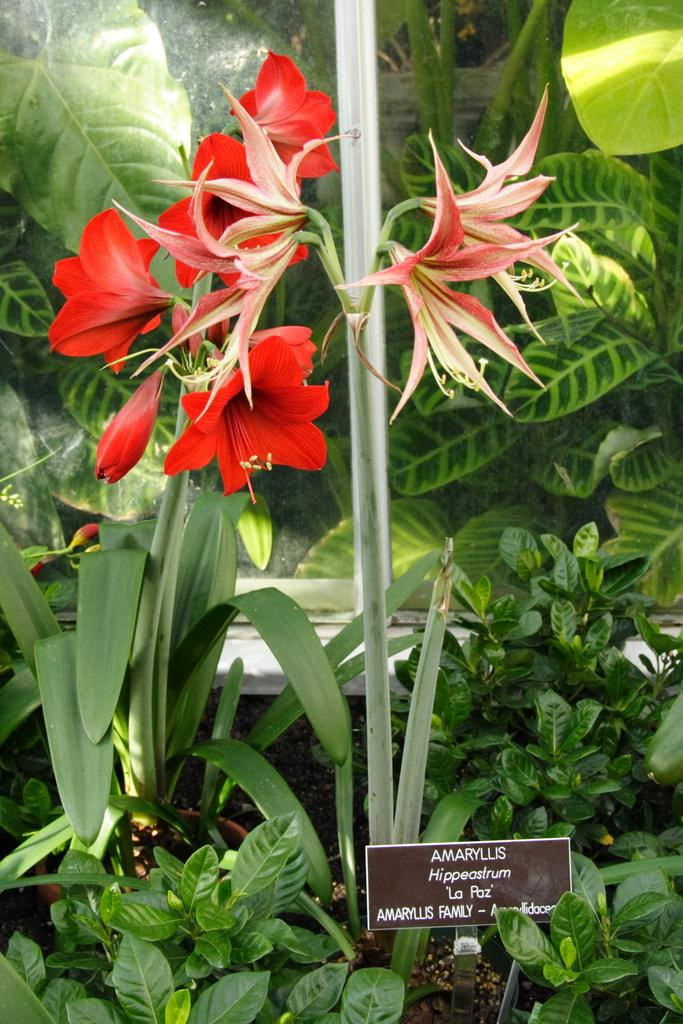What type of plant is in the image? There is a plant in the image with red flowers and green leaves. What colors are present in the plant? The plant has red flowers and green leaves. What else can be seen in the image besides the plant? There is a brown color board in the image. What is the purpose of the board? Something is written on the board, suggesting it may be used for communication or displaying information. Where is the crowd gathered around the plant in the image? There is no crowd present in the image; it only features the plant and the brown color board. What type of pie is being served at the playground in the image? There is no pie or playground present in the image; it only features the plant and the brown color board. 